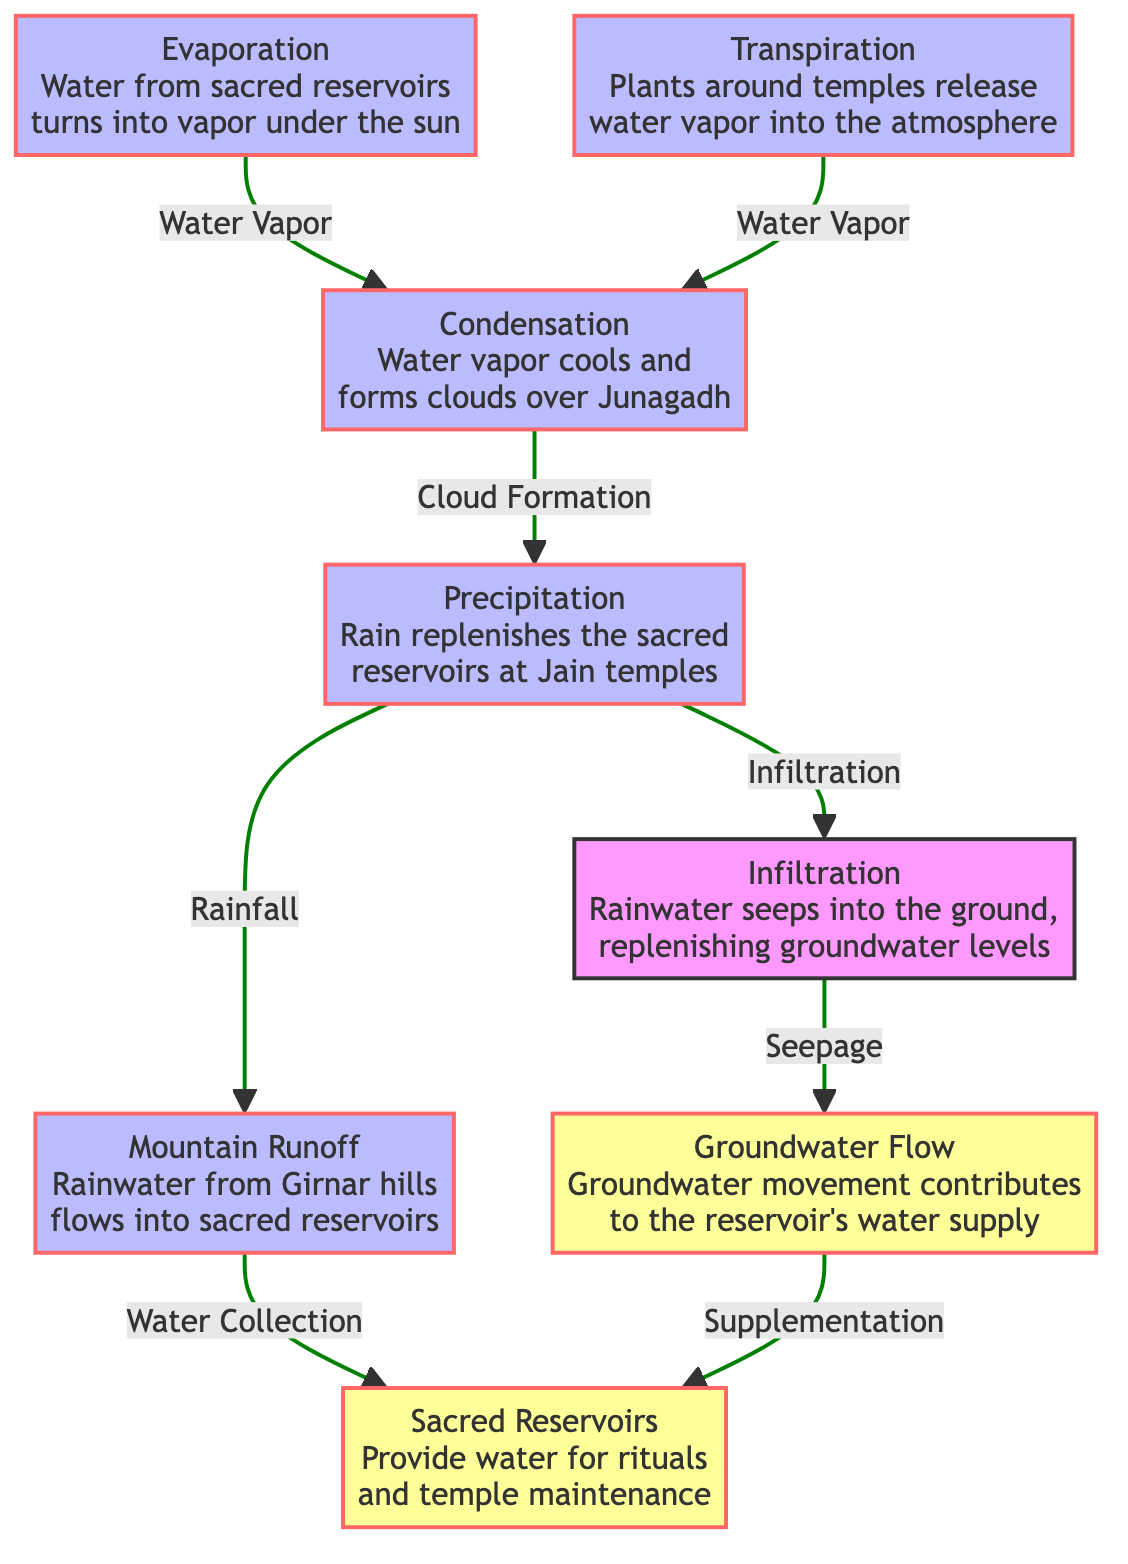What is the first process in the water cycle shown? The first process shown in the diagram is Evaporation, which describes how water from sacred reservoirs turns into vapor under the sun. This can be seen at the node labeled "Evaporation".
Answer: Evaporation How many main processes are illustrated in the diagram? The diagram illustrates a total of 7 main processes that contribute to the water cycle and influence the sacred reservoirs. Each process is represented by a distinct node.
Answer: 7 What does rain replenish according to the diagram? The diagram shows that rain replenishes the sacred reservoirs at Jain temples. This is clearly stated in the node labeled "Precipitation", which directly points to the node "Sacred Reservoirs".
Answer: Sacred Reservoirs What role does transpiration play in the diagram? Transpiration involves plants around the temples releasing water vapor into the atmosphere, which contributes to the atmospheric moisture. This process connects back to condensation, indicating its role in the water cycle.
Answer: Water Vapor Which process leads to the infiltration of rainwater? The process that leads to the infiltration of rainwater is "Precipitation". It describes rainfall that seeps into the ground to replenish groundwater levels, as indicated in the flow from "Precipitation" to "Infiltration".
Answer: Precipitation Which natural feature contributes to the collection of rainwater? The Girnar hills contribute to mountain runoff, which flows into the sacred reservoirs. This connection is highlighted in the flow from the "Mountain Runoff" process to the "Sacred Reservoirs".
Answer: Girnar hills What two processes are connected through infiltration? The processes connected through infiltration are "Precipitation" and "Groundwater Flow". Rainwater infiltrates into the ground and contributes to groundwater movement, replenishing the reservoirs.
Answer: Precipitation and Groundwater Flow What influences cloud formation in the diagram? Cloud formation is influenced by "Condensation", where water vapor cools and aggregates, leading to cloud formation over Junagadh. This is derived from the transition from "Evaporation" to "Condensation".
Answer: Condensation What term is used for the water stored in the sacred reservoirs? The term used for the water stored in the sacred reservoirs is "Sacred Reservoirs". This is explicitly labeled in the diagram as storage for rituals and temple maintenance.
Answer: Sacred Reservoirs 